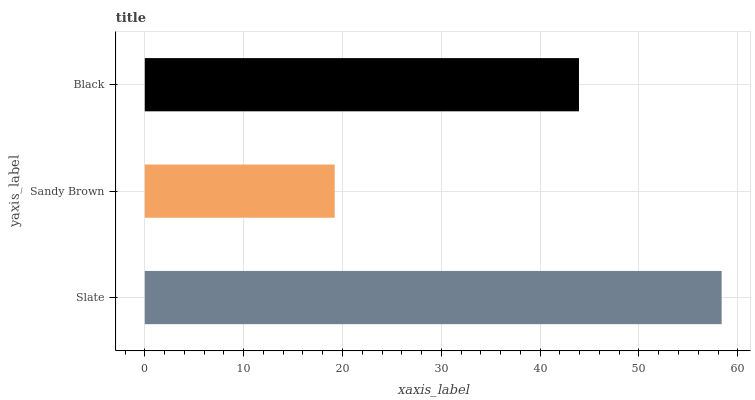Is Sandy Brown the minimum?
Answer yes or no. Yes. Is Slate the maximum?
Answer yes or no. Yes. Is Black the minimum?
Answer yes or no. No. Is Black the maximum?
Answer yes or no. No. Is Black greater than Sandy Brown?
Answer yes or no. Yes. Is Sandy Brown less than Black?
Answer yes or no. Yes. Is Sandy Brown greater than Black?
Answer yes or no. No. Is Black less than Sandy Brown?
Answer yes or no. No. Is Black the high median?
Answer yes or no. Yes. Is Black the low median?
Answer yes or no. Yes. Is Slate the high median?
Answer yes or no. No. Is Sandy Brown the low median?
Answer yes or no. No. 